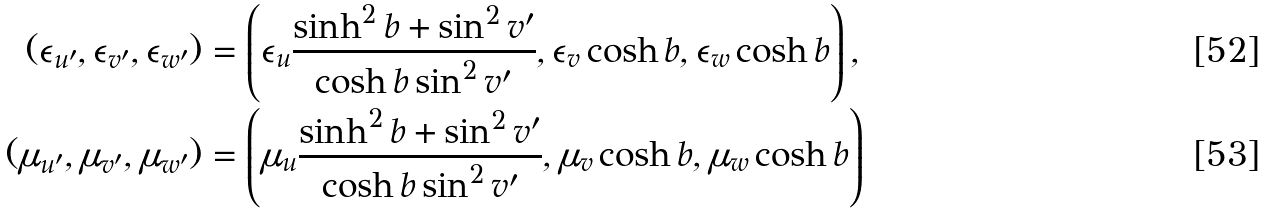<formula> <loc_0><loc_0><loc_500><loc_500>( \epsilon _ { u ^ { \prime } } , \epsilon _ { v ^ { \prime } } , \epsilon _ { w ^ { \prime } } ) & = \left ( \epsilon _ { u } \frac { \sinh ^ { 2 } b + \sin ^ { 2 } v ^ { \prime } } { \cosh b \sin ^ { 2 } v ^ { \prime } } , \epsilon _ { v } \cosh b , \epsilon _ { w } \cosh b \right ) , \\ ( \mu _ { u ^ { \prime } } , \mu _ { v ^ { \prime } } , \mu _ { w ^ { \prime } } ) & = \left ( \mu _ { u } \frac { \sinh ^ { 2 } b + \sin ^ { 2 } v ^ { \prime } } { \cosh b \sin ^ { 2 } v ^ { \prime } } , \mu _ { v } \cosh b , \mu _ { w } \cosh b \right )</formula> 